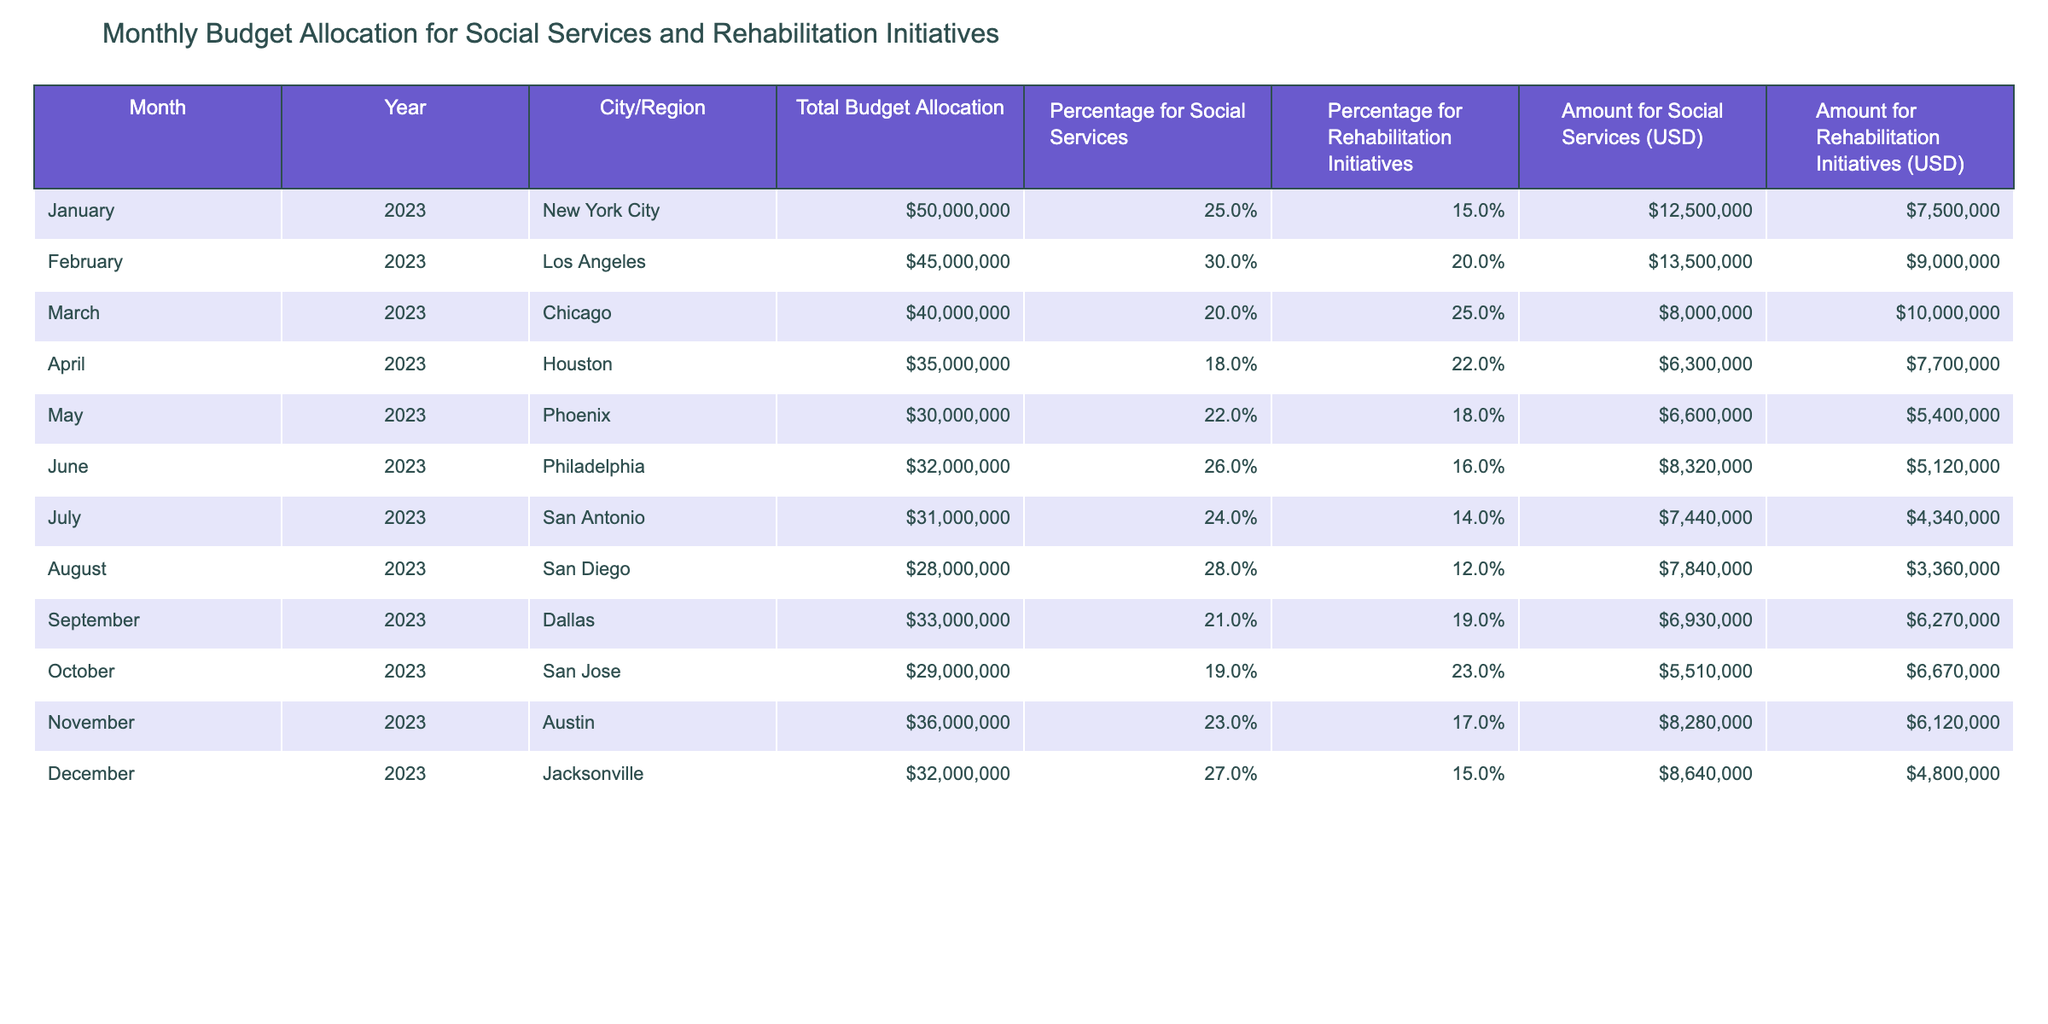What is the total budget allocation for April 2023? According to the table, the total budget allocation listed for April 2023 is $35,000,000.
Answer: $35,000,000 Which city had the highest amount allocated for social services in January 2023? The table shows that New York City had the highest amount allocated for social services in January 2023, which is $12,500,000.
Answer: New York City What is the average percentage allocated for rehabilitation initiatives across all months? To find the average percentage, sum the percentages for rehabilitation initiatives for each month: 15% + 20% + 25% + 22% + 18% + 16% + 14% + 12% + 19% + 23% + 17% + 15% =  225%. Then divide by 12, which gives us 18.75%.
Answer: 18.75% Is the amount allocated for rehabilitation initiatives in December 2023 less than $5 million? The table indicates that the amount allocated for rehabilitation initiatives in December 2023 is $4,800,000, which is less than $5 million.
Answer: Yes Which region has the lowest total budget allocation for the year, and what is that amount? By comparing the total budget allocations, Phoenix has the lowest total budget allocation for the year at $30,000,000.
Answer: Phoenix, $30,000,000 What is the combined amount allocated for social services and rehabilitation initiatives for San Antonio in July 2023? The amount for social services is $7,440,000 and for rehabilitation initiatives it's $4,340,000. Adding these two amounts gives us $7,440,000 + $4,340,000 = $11,780,000.
Answer: $11,780,000 Which month has the highest percentage allocated for social services, and what is that percentage? Looking through the table, February 2023 shows the highest percentage for social services at 30%.
Answer: February 2023, 30% If we look at the total budget allocated to Chicago and San Diego, which city has a higher allocation? The total budget for Chicago is $40,000,000, while for San Diego it is $28,000,000. Therefore, Chicago has a higher allocation than San Diego.
Answer: Chicago What is the total amount allocated for social services in 2023 compared to the amount allocated for rehabilitation initiatives? To find this, sum the amounts for social services (totaling $77,960,000) and the amounts for rehabilitation initiatives (totaling $59,400,000). Thus, social services have more allocated than rehabilitation initiatives.
Answer: Social services, $77,960,000; Rehabilitation initiatives, $59,400,000 